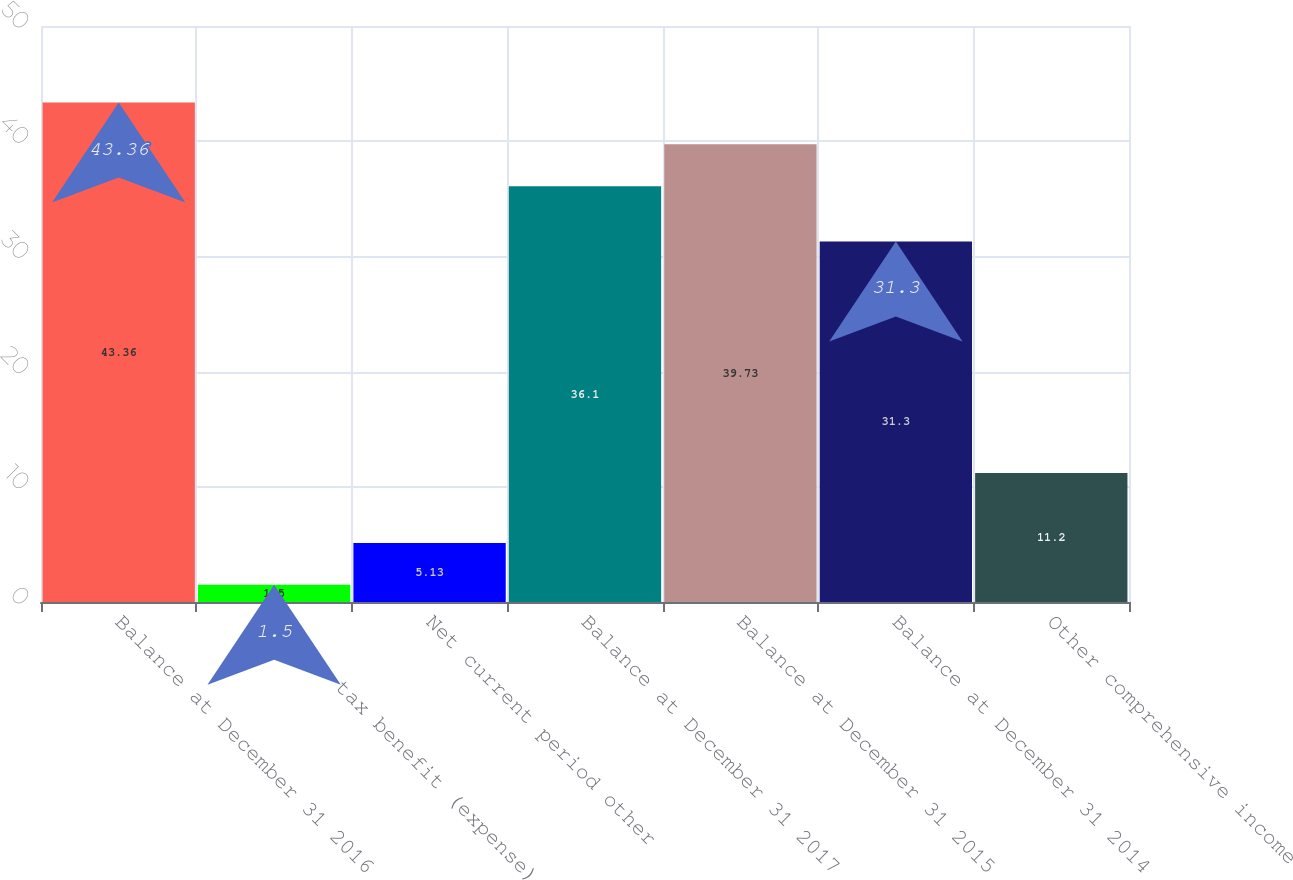Convert chart to OTSL. <chart><loc_0><loc_0><loc_500><loc_500><bar_chart><fcel>Balance at December 31 2016<fcel>Income tax benefit (expense)<fcel>Net current period other<fcel>Balance at December 31 2017<fcel>Balance at December 31 2015<fcel>Balance at December 31 2014<fcel>Other comprehensive income<nl><fcel>43.36<fcel>1.5<fcel>5.13<fcel>36.1<fcel>39.73<fcel>31.3<fcel>11.2<nl></chart> 